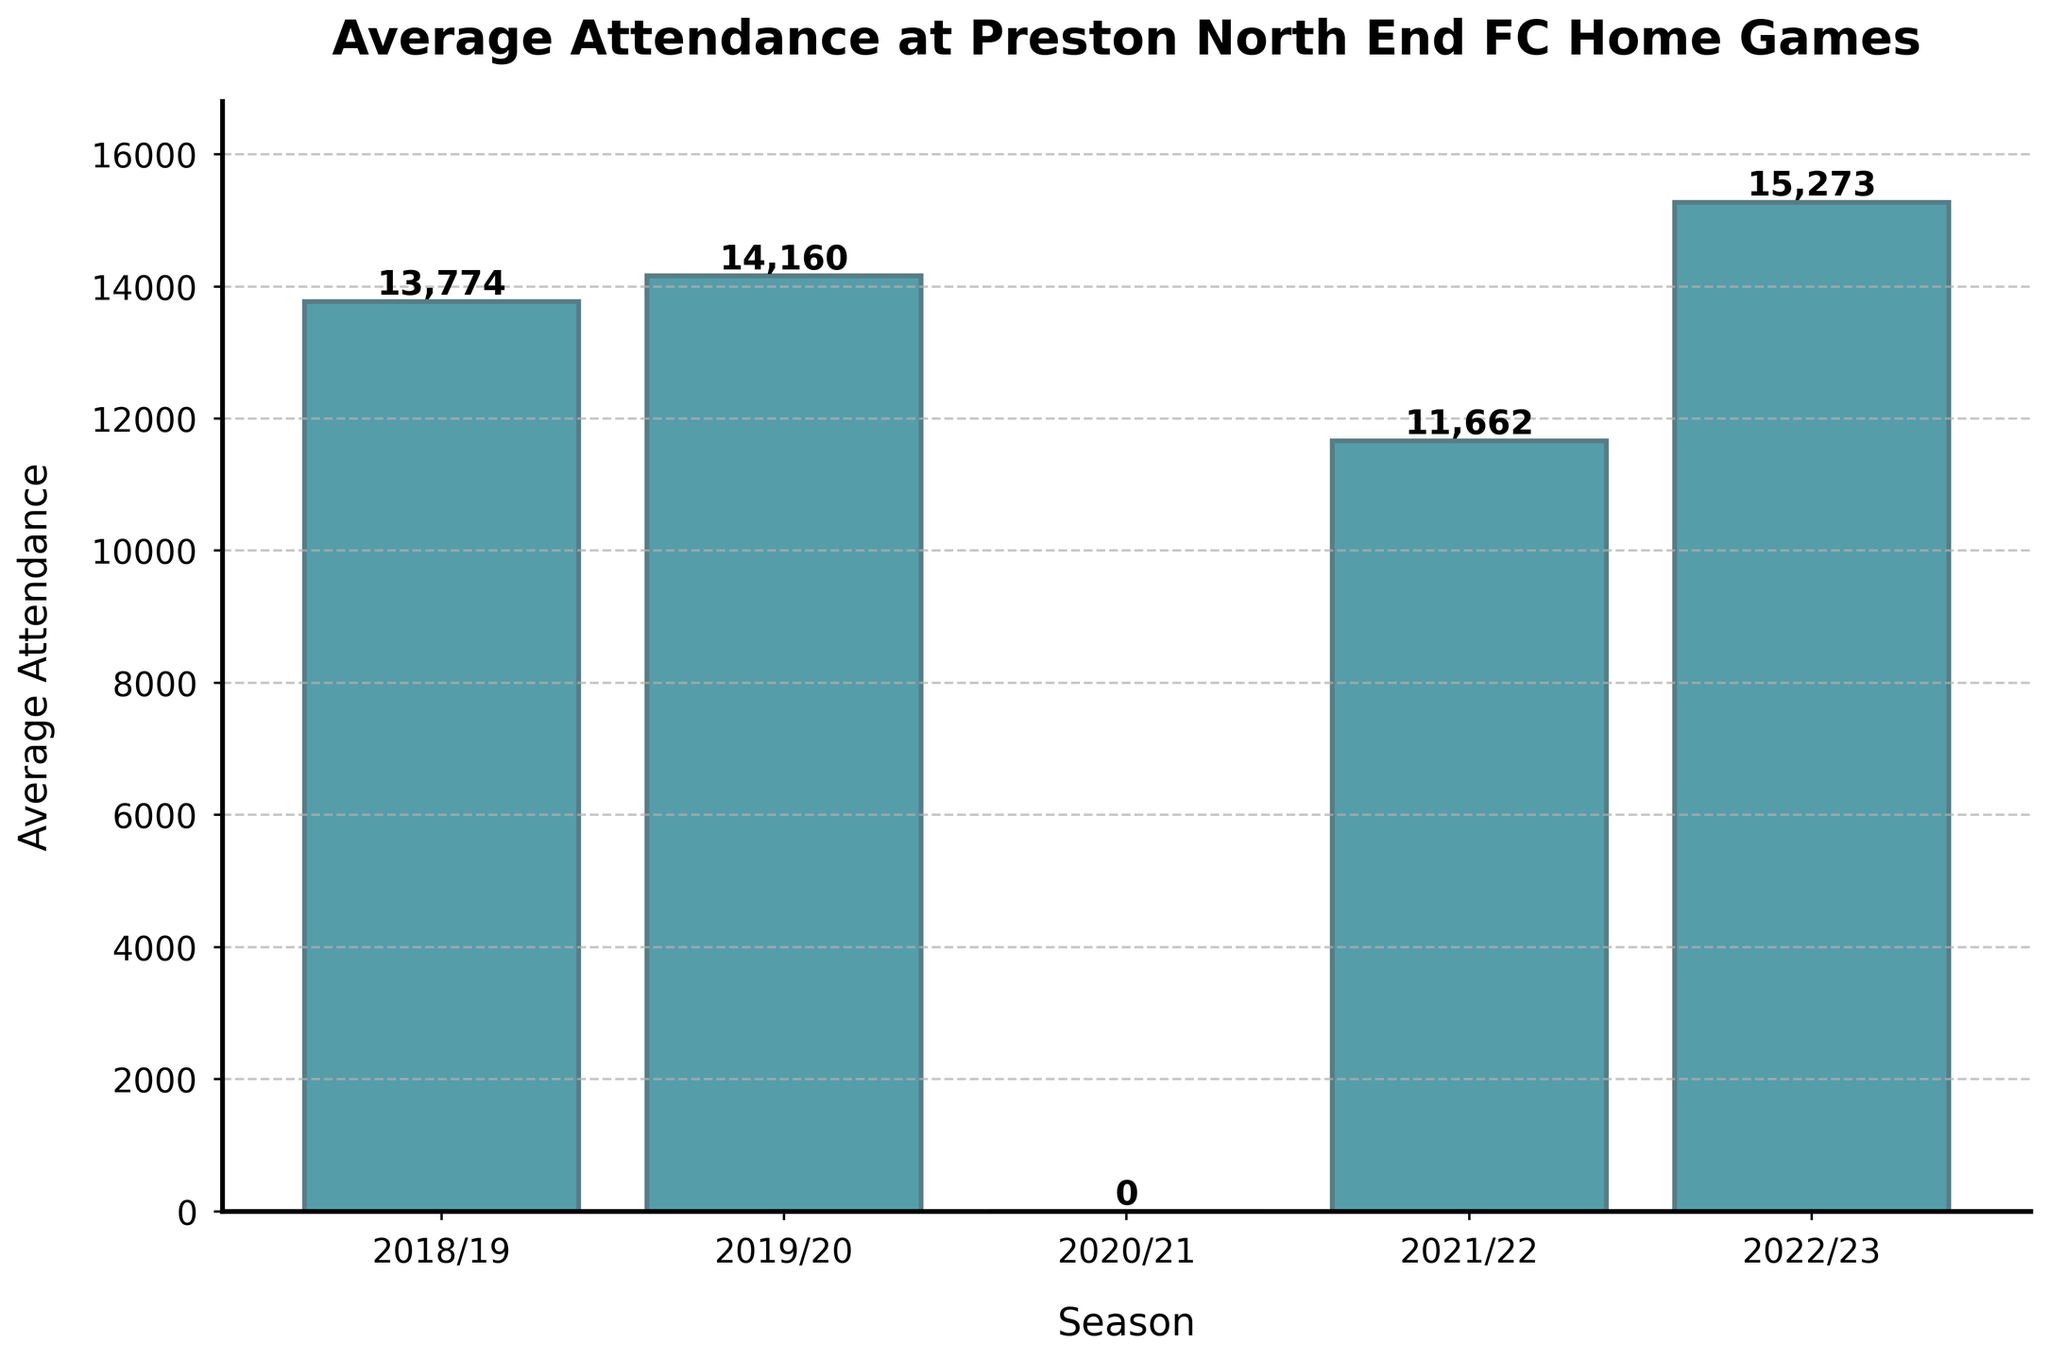What is the average attendance for the 2019/20 season? Find the bar labeled 2019/20 and read the value at the top of the bar, which is 14,160
Answer: 14,160 Which season had the lowest average attendance? Observe the heights of all bars. The bar for 2020/21 is the shortest and has a value of 0, indicating the lowest average attendance
Answer: 2020/21 What is the difference in average attendance between the 2018/19 and 2022/23 seasons? Read the values for both seasons: 2018/19 is 13,774 and 2022/23 is 15,273. Subtract the former from the latter: 15,273 - 13,774 = 1,499
Answer: 1,499 How did the average attendance change from 2019/20 to 2020/21? The bar for 2019/20 shows 14,160 while 2020/21 shows 0. The difference is 14,160 - 0 = 14,160, indicating a decrease
Answer: Decreased by 14,160 Which two consecutive seasons show the largest increase in average attendance? Compare differences between consecutive seasons: from 2020/21 to 2021/22 (0 to 11,662, an increase of 11,662) and from 2021/22 to 2022/23 (11,662 to 15,273, an increase of 3,611). The largest increase is from 2020/21 to 2021/22
Answer: 2020/21 to 2021/22 What is the total average attendance over the five seasons? Sum the average attendances: 13,774 + 14,160 + 0 + 11,662 + 15,273 = 54,869
Answer: 54,869 Which season had an average attendance closest to 12,000? Compare all average attendance values to 12,000. The closest is 11,662 in the 2021/22 season
Answer: 2021/22 Which season had the highest average attendance? Look for the tallest bar. The 2022/23 season shows the highest average attendance of 15,273
Answer: 2022/23 